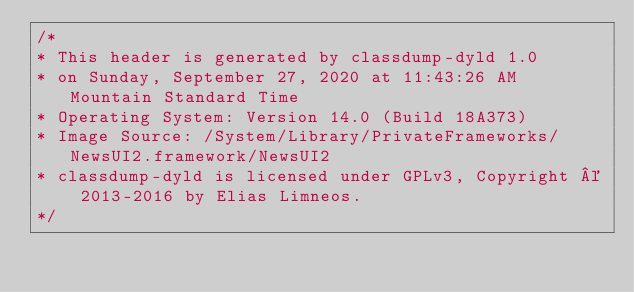Convert code to text. <code><loc_0><loc_0><loc_500><loc_500><_C_>/*
* This header is generated by classdump-dyld 1.0
* on Sunday, September 27, 2020 at 11:43:26 AM Mountain Standard Time
* Operating System: Version 14.0 (Build 18A373)
* Image Source: /System/Library/PrivateFrameworks/NewsUI2.framework/NewsUI2
* classdump-dyld is licensed under GPLv3, Copyright © 2013-2016 by Elias Limneos.
*/

</code> 